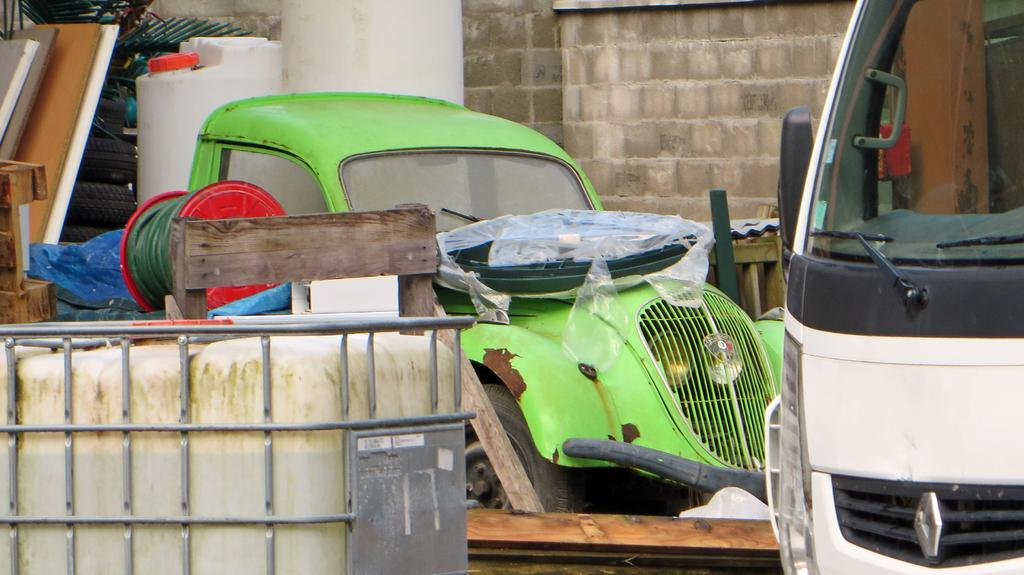What types of vehicles can be seen in the image? There are vehicles in the image, but the specific types cannot be determined from the provided facts. What kind of wooden objects are present in the image? There are wooden objects in the image, but their specific nature cannot be determined from the provided facts. What part of the vehicles can be seen in the image? Tires are visible in the image. What type of structure is present in the image? There is a wall in the image. What material is used for some of the objects in the image? Iron materials are present in the image. Can you describe any other objects in the image? There are other objects present in the image, but their specific nature cannot be determined from the provided facts. Can you tell me how many basketballs are visible in the image? There are no basketballs present in the image. What type of shock can be seen affecting the vehicles in the image? There is no shock affecting the vehicles in the image; they appear stationary. 